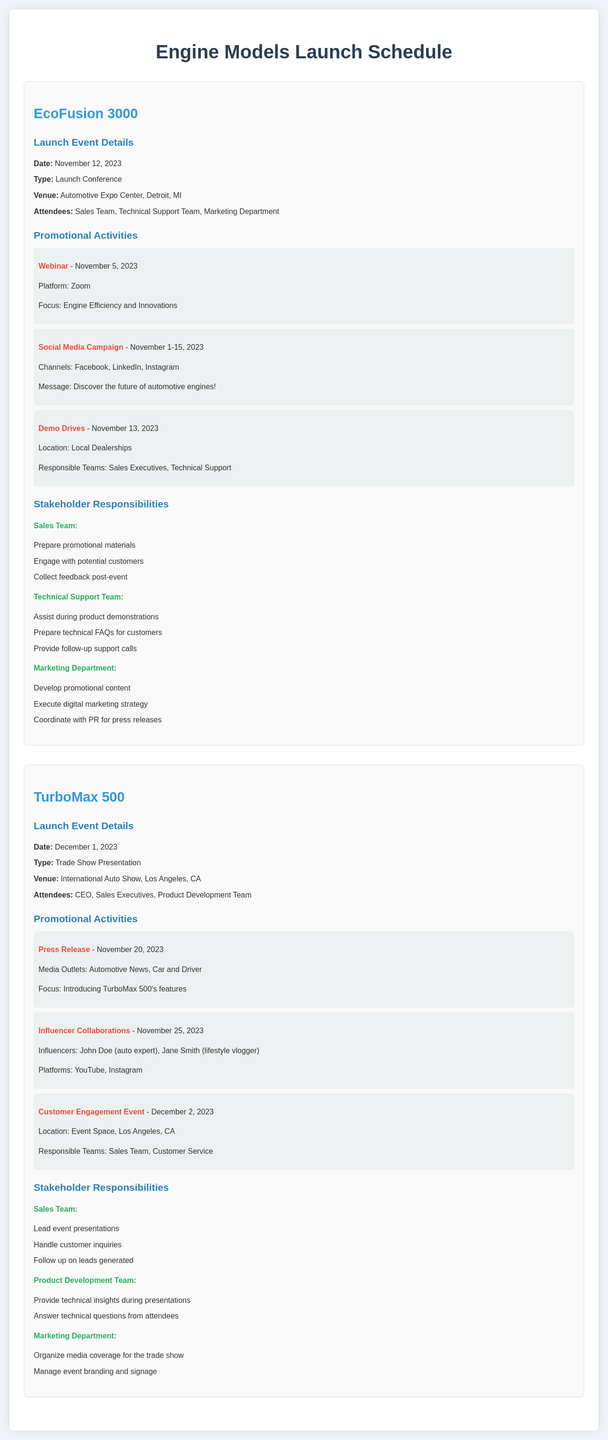What is the launch date for the EcoFusion 3000? The launch date is specified in the event details section for EcoFusion 3000.
Answer: November 12, 2023 What type of event is the TurboMax 500 launch? The type of event is detailed under the launch event for TurboMax 500.
Answer: Trade Show Presentation Where is the EcoFusion 3000 launch event being held? The venue for the EcoFusion 3000 launch is clearly mentioned in the event details.
Answer: Automotive Expo Center, Detroit, MI Who attends the TurboMax 500 launch? The attendees for the TurboMax 500 event are listed in the event details section.
Answer: CEO, Sales Executives, Product Development Team What promotional activity occurs on November 5, 2023, for the EcoFusion 3000? This activity is mentioned in the promotional activities section for EcoFusion 3000.
Answer: Webinar How many promotional activities are scheduled for the EcoFusion 3000? The number of activities can be counted from the activities listed under EcoFusion 3000.
Answer: Three Which team is responsible for the Demo Drives associated with the EcoFusion 3000? The responsible teams for this activity are specified in the promotional activities section for EcoFusion 3000.
Answer: Sales Executives, Technical Support What is the focus of the press release for TurboMax 500? The focus of the press release is described in the promotional activities section for TurboMax 500.
Answer: Introducing TurboMax 500's features What are sales team's responsibilities for the TurboMax 500 launch? The sales team's responsibilities are listed under stakeholder responsibilities for TurboMax 500.
Answer: Lead event presentations, Handle customer inquiries, Follow up on leads generated 